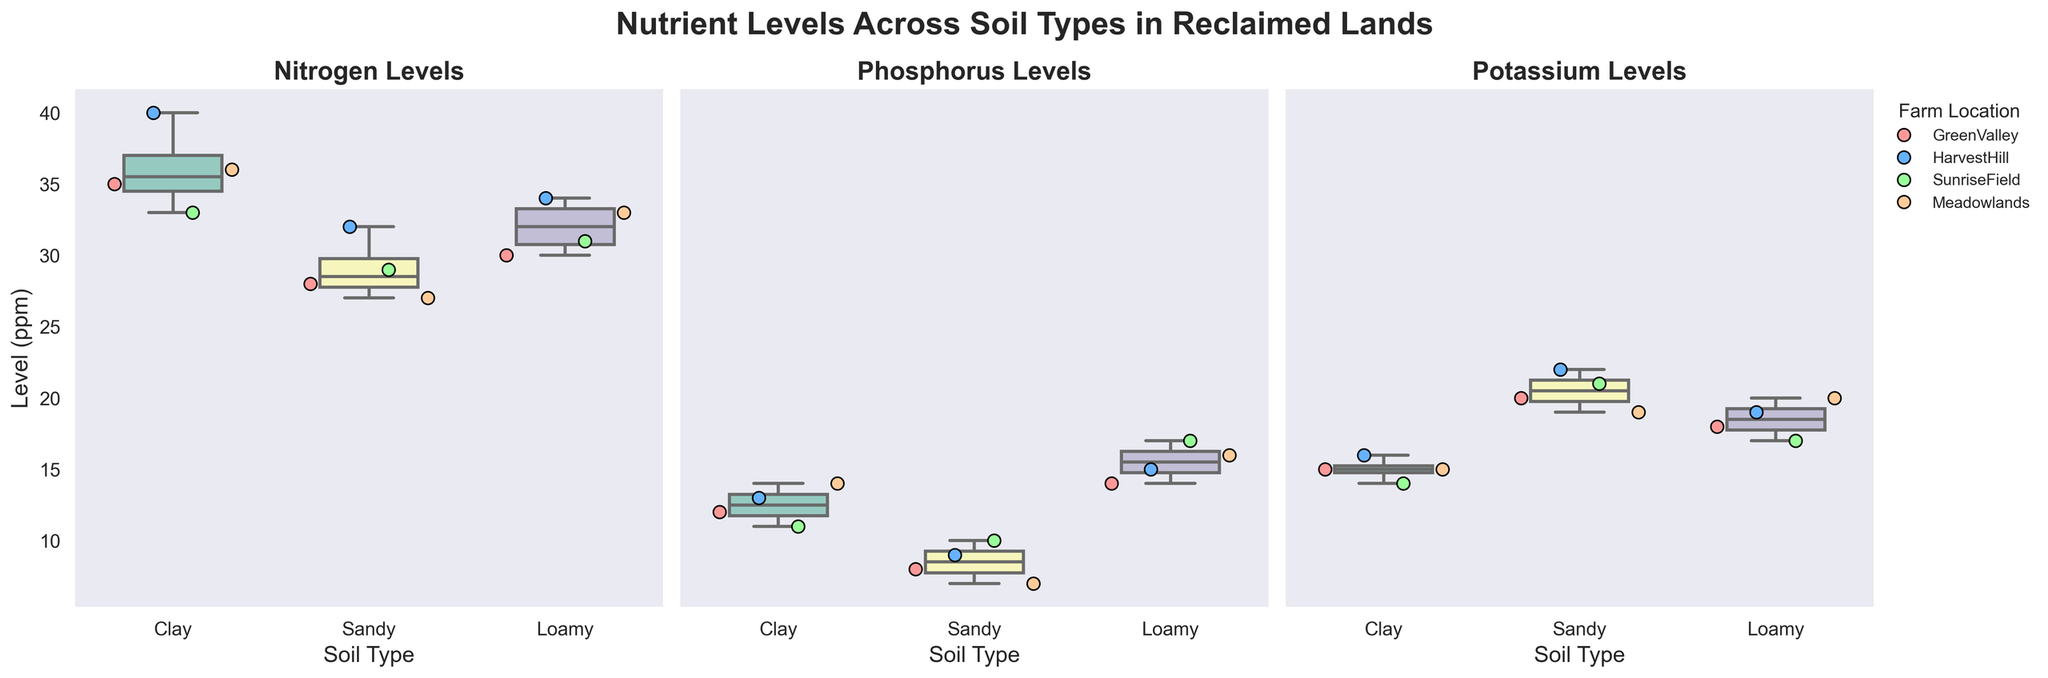What is the title of the figure? The title is located at the top of the figure, and it clearly states the purpose of the figure. The title is "Nutrient Levels Across Soil Types in Reclaimed Lands".
Answer: Nutrient Levels Across Soil Types in Reclaimed Lands How many subplots are there in the figure? The figure contains a total of three boxplot subplots.
Answer: Three Which soil type shows the highest median level of Nitrogen? To determine the highest median level of Nitrogen, look at the middle line within each box on the Nitrogen subplot. The one that is the highest corresponds to the soil type.
Answer: Clay What is the range of Phosphorus levels in Clay soil? The range is determined by looking at the minimum and maximum 'whisker' lines in the Phosphorus subplot for Clay soil.
Answer: 7 to 14 ppm Which farm location shows greater variation in Potassium levels in Sandy soil? Variation is represented by the length of the box and whiskers in the subplot, and we should check the spread within the Potassium levels for Sandy soil while considering each farm location.
Answer: HarvestHill How do the median Phosphorus levels compare across different soil types? Compare the middle lines within each box in the Phosphorus subplot for Clay, Sandy, and Loamy soils. The Loamy soil type has the highest median, followed by Clay, and then Sandy.
Answer: Loamy > Clay > Sandy What is the interquartile range (IQR) of Potassium levels in Loamy soil? The IQR is calculated as the difference between the upper quartile (Q3) and the lower quartile (Q1) within the box of the Potassium subplot for Loamy soil.
Answer: 17 to 20 ppm Which nutrient shows the widest range of levels across all soil types? Determine which subplot's whiskers show the widest overall spread from the lowest to highest points, representing the largest range of levels.
Answer: Nitrogen Do all farm locations have similar levels of Phosphorus in Loamy soil? Look for the distribution and positioning of individual data points (strip plot) for each farm location within the Loamy soil section of the Phosphorus subplot.
Answer: No, there are variations Which farm location has the highest data point in the Nitrogen subplot within Clay soil? Identify the outlier data point within Clay soil of the Nitrogen subplot and note the corresponding farm location.
Answer: HarvestHill 